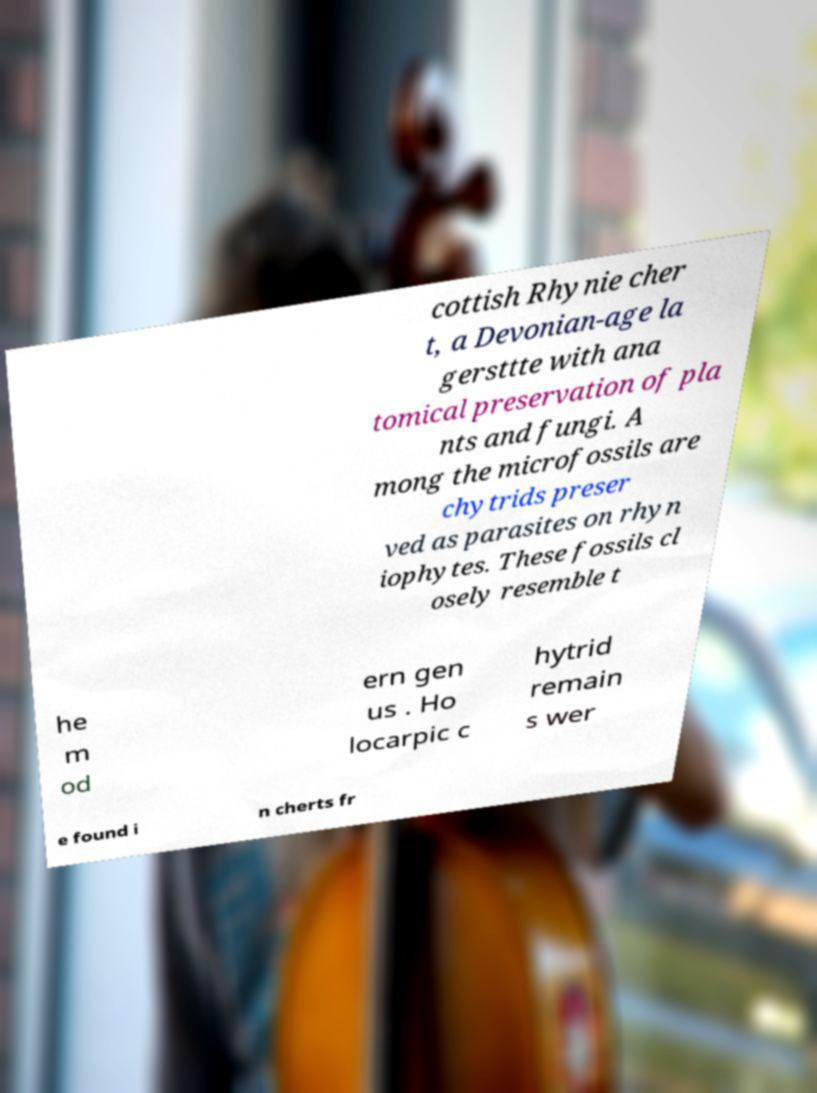Please identify and transcribe the text found in this image. cottish Rhynie cher t, a Devonian-age la gersttte with ana tomical preservation of pla nts and fungi. A mong the microfossils are chytrids preser ved as parasites on rhyn iophytes. These fossils cl osely resemble t he m od ern gen us . Ho locarpic c hytrid remain s wer e found i n cherts fr 